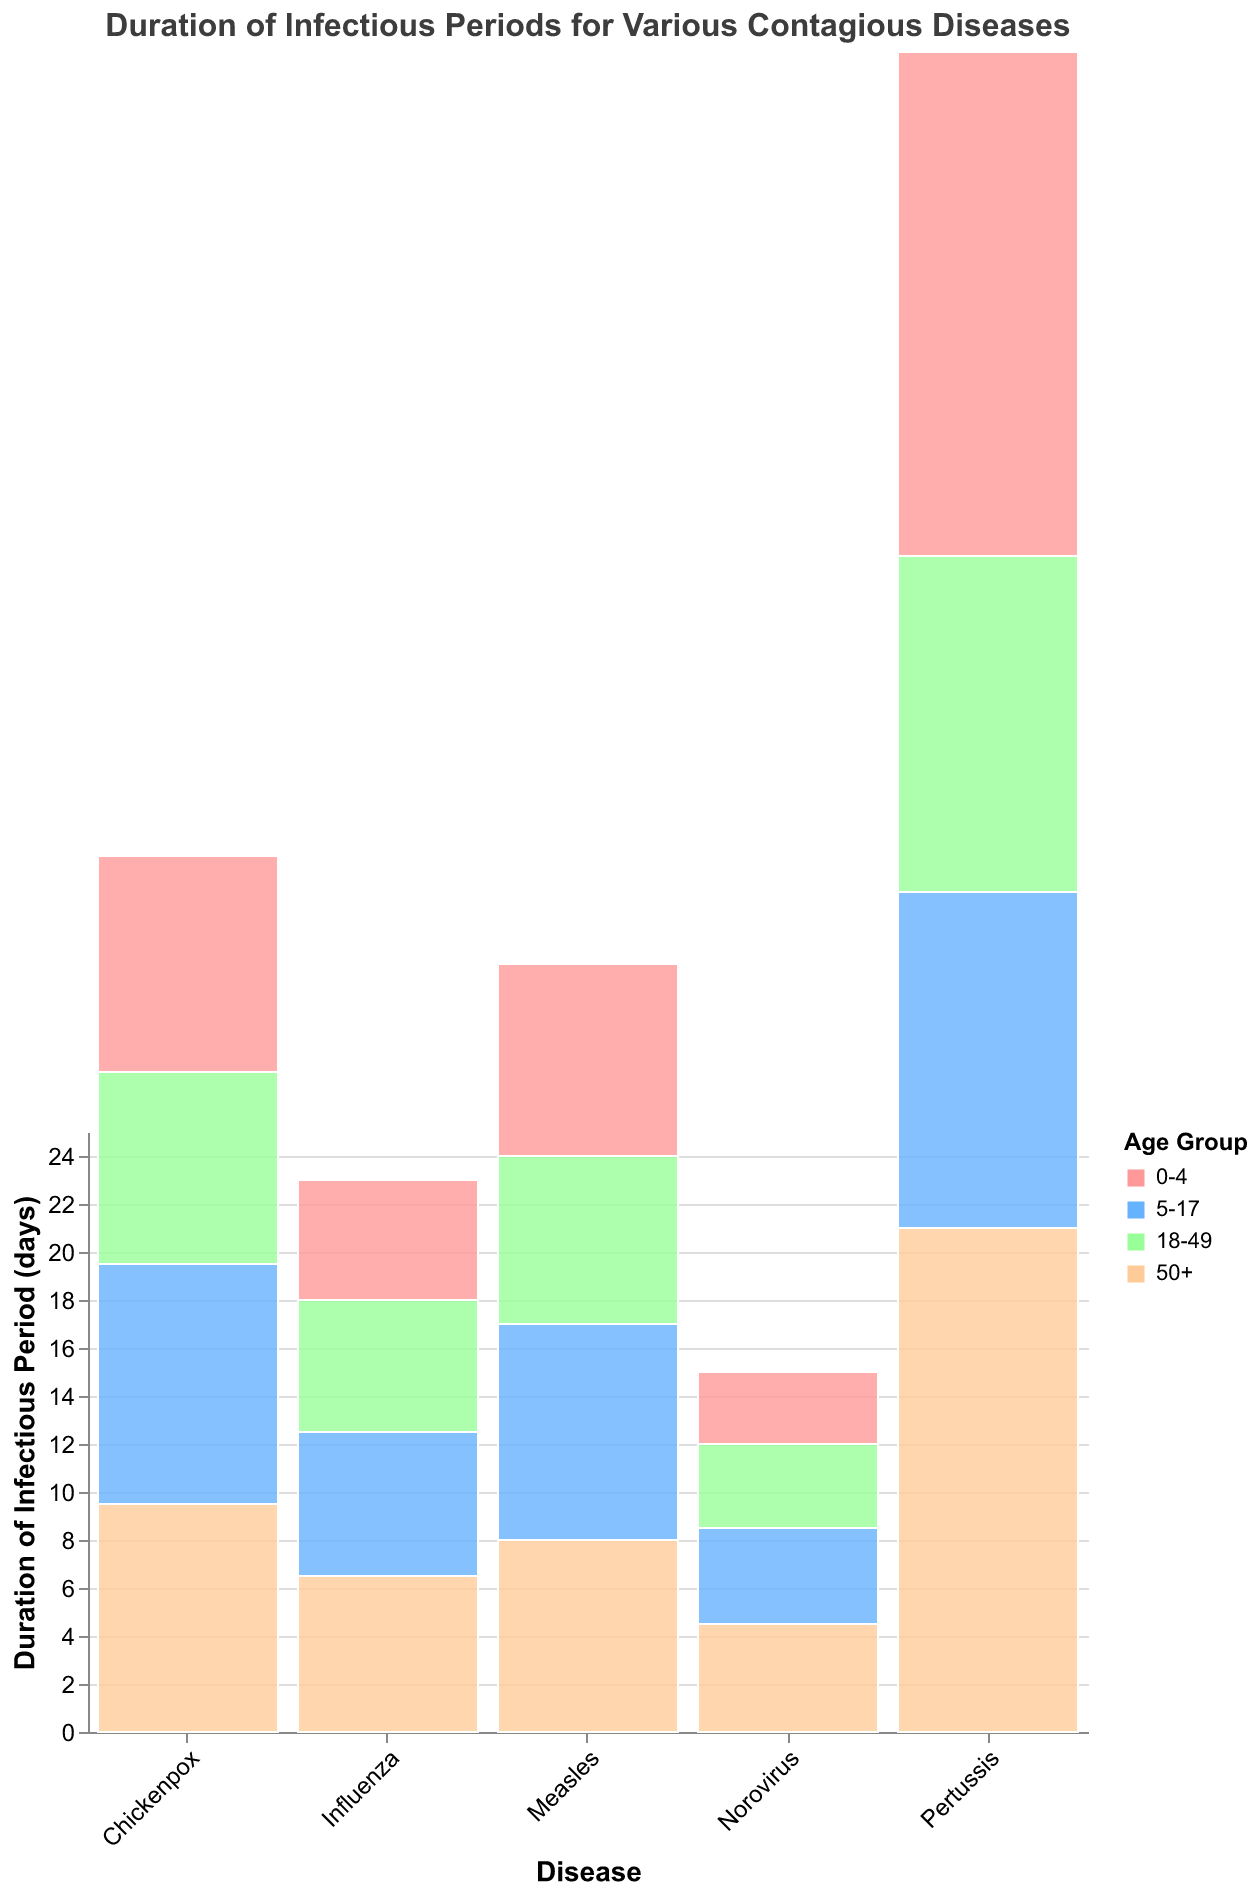What is the title of the figure? The title is typically displayed at the top of the figure. In this case, it states "Duration of Infectious Periods for Various Contagious Diseases".
Answer: Duration of Infectious Periods for Various Contagious Diseases Which age group has the longest duration of the infectious period for Pertussis? To answer this, look at the bars corresponding to Pertussis and identify the one with the highest value. Both the 0-4 and 50+ age groups have the highest values of 21 days.
Answer: 0-4 and 50+ What is the average duration of the infectious period for Influenza across all age groups? First, add the durations for all age groups: 5 (0-4) + 6 (5-17) + 5.5 (18-49) + 6.5 (50+) = 23. Divide by the number of age groups, which is 4. The average is 23 / 4 = 5.75 days.
Answer: 5.75 days How does the infectious period duration for Norovirus in the 50+ age group compare to that in the 0-4 age group? Compare the heights of the bars for Norovirus in the 50+ and 0-4 age groups. The duration is 4.5 days for 50+ and 3 days for 0-4, so the duration is longer in the 50+ group.
Answer: Longer Which disease has the shortest infectious period for the 5-17 age group? Look at the bars corresponding to the 5-17 age group and identify the disease with the smallest value. Norovirus has the shortest infectious period with 4 days.
Answer: Norovirus For which age group is the infectious period of Chickenpox the longest? Compare the bar heights for Chickenpox across all age groups. The 5-17 age group has the longest period with a duration of 10 days.
Answer: 5-17 What is the difference in the duration of the infectious period for Chickenpox and Influenza in the 50+ age group? Find the values for Chickenpox (9.5 days) and Influenza (6.5 days) in the 50+ age group and subtract the smaller value from the larger one: 9.5 - 6.5 = 3 days.
Answer: 3 days Which disease has the most variation in the duration of the infectious period across different age groups? To determine this, compare the range of durations within each disease. Pertussis varies from 14 to 21 days (a range of 7 days), which is the greatest variation.
Answer: Pertussis 